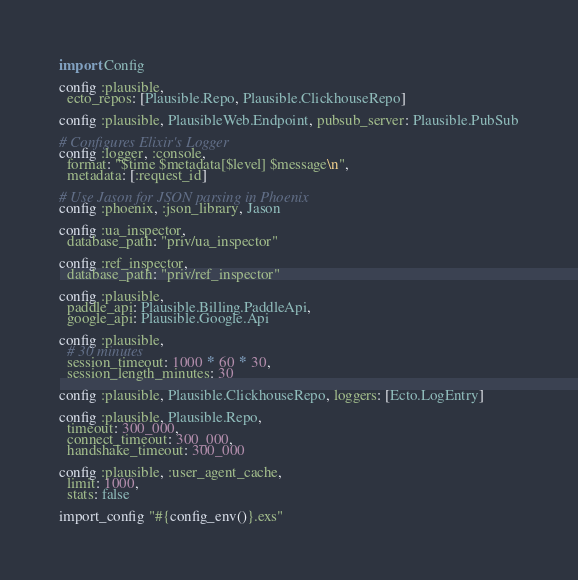Convert code to text. <code><loc_0><loc_0><loc_500><loc_500><_Elixir_>import Config

config :plausible,
  ecto_repos: [Plausible.Repo, Plausible.ClickhouseRepo]

config :plausible, PlausibleWeb.Endpoint, pubsub_server: Plausible.PubSub

# Configures Elixir's Logger
config :logger, :console,
  format: "$time $metadata[$level] $message\n",
  metadata: [:request_id]

# Use Jason for JSON parsing in Phoenix
config :phoenix, :json_library, Jason

config :ua_inspector,
  database_path: "priv/ua_inspector"

config :ref_inspector,
  database_path: "priv/ref_inspector"

config :plausible,
  paddle_api: Plausible.Billing.PaddleApi,
  google_api: Plausible.Google.Api

config :plausible,
  # 30 minutes
  session_timeout: 1000 * 60 * 30,
  session_length_minutes: 30

config :plausible, Plausible.ClickhouseRepo, loggers: [Ecto.LogEntry]

config :plausible, Plausible.Repo,
  timeout: 300_000,
  connect_timeout: 300_000,
  handshake_timeout: 300_000

config :plausible, :user_agent_cache,
  limit: 1000,
  stats: false

import_config "#{config_env()}.exs"
</code> 